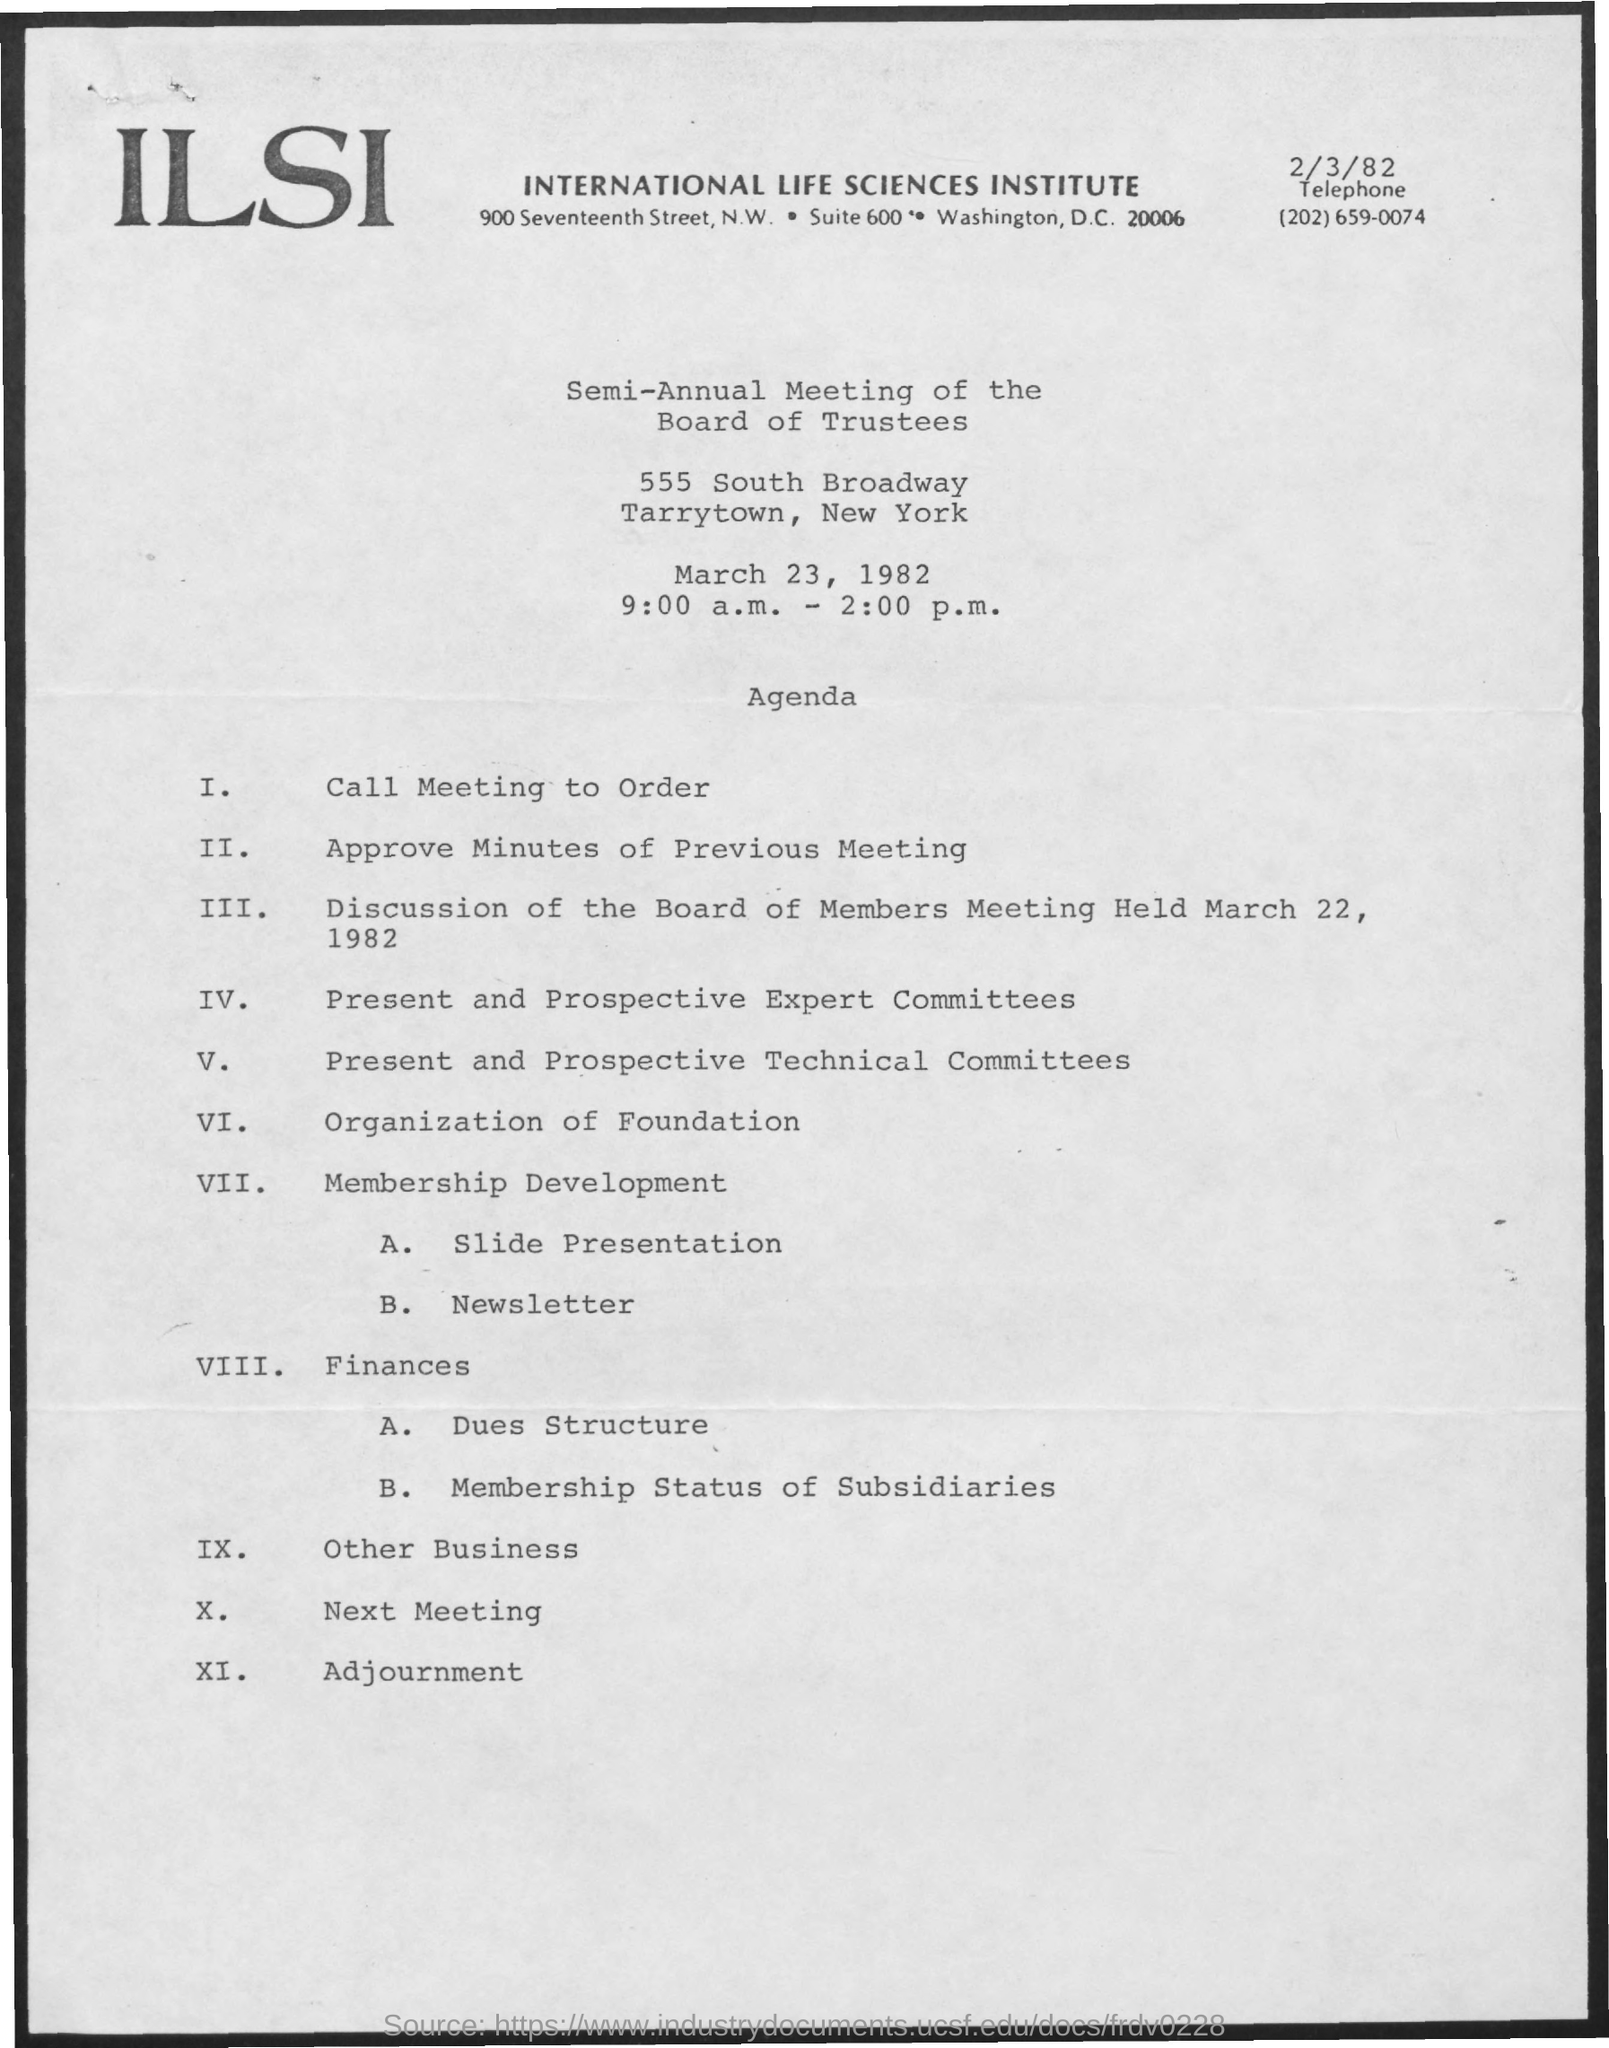What is the full form of ILSI?
Make the answer very short. International life sciences institute. The meeting is scheduled on which date?
Your answer should be very brief. March 23,1982. 